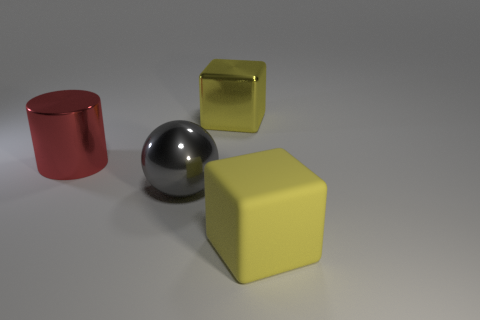Add 1 tiny yellow matte balls. How many objects exist? 5 Subtract all cylinders. How many objects are left? 3 Subtract all small purple cubes. Subtract all big metal objects. How many objects are left? 1 Add 1 matte things. How many matte things are left? 2 Add 2 large red metallic objects. How many large red metallic objects exist? 3 Subtract 1 red cylinders. How many objects are left? 3 